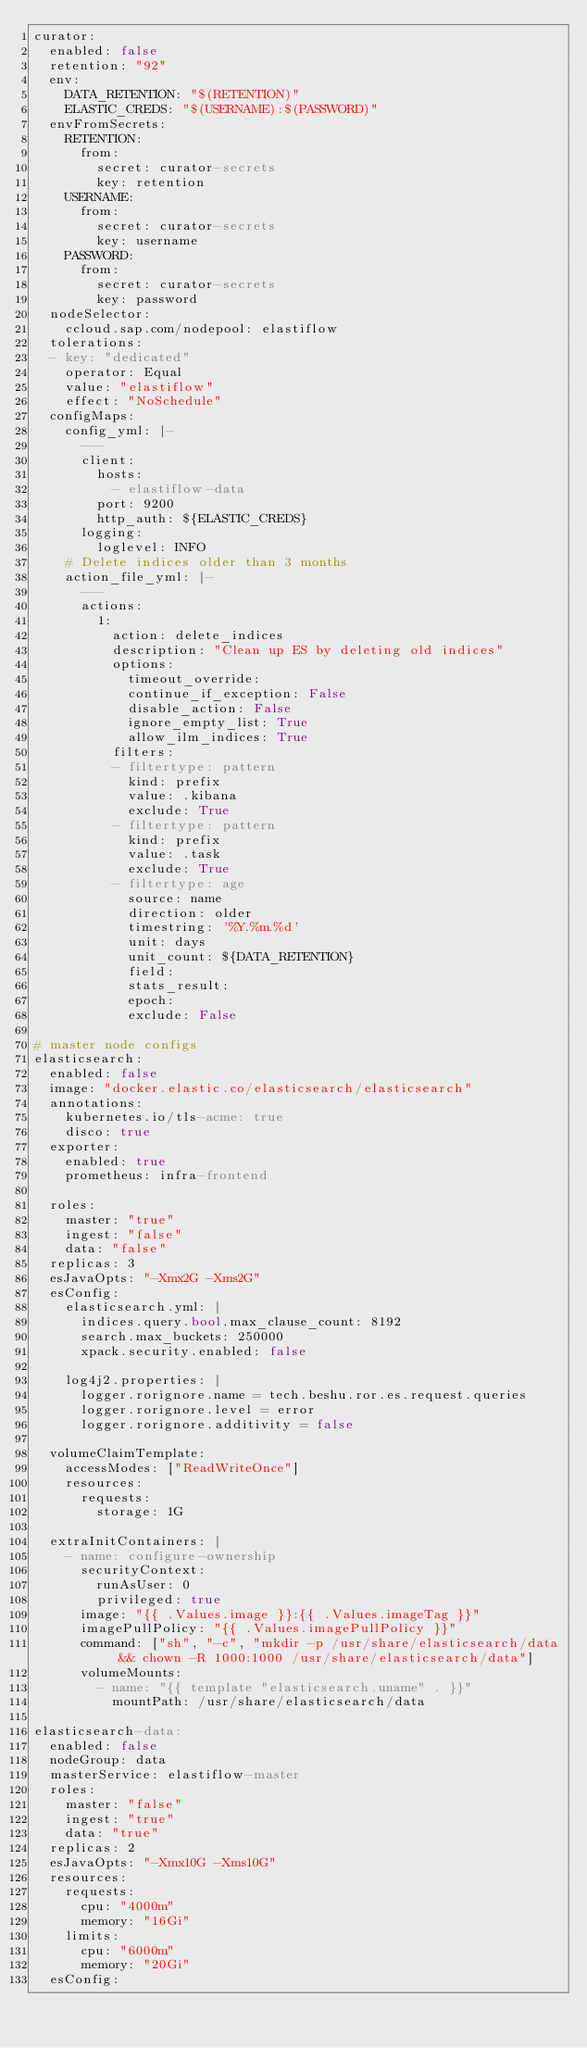Convert code to text. <code><loc_0><loc_0><loc_500><loc_500><_YAML_>curator:
  enabled: false
  retention: "92"
  env:
    DATA_RETENTION: "$(RETENTION)"
    ELASTIC_CREDS: "$(USERNAME):$(PASSWORD)"
  envFromSecrets:
    RETENTION:
      from:
        secret: curator-secrets
        key: retention
    USERNAME:
      from:
        secret: curator-secrets
        key: username
    PASSWORD:
      from:
        secret: curator-secrets
        key: password
  nodeSelector:
    ccloud.sap.com/nodepool: elastiflow
  tolerations:
  - key: "dedicated"
    operator: Equal
    value: "elastiflow"
    effect: "NoSchedule"
  configMaps:
    config_yml: |-
      ---
      client:
        hosts:
          - elastiflow-data
        port: 9200
        http_auth: ${ELASTIC_CREDS}
      logging:
        loglevel: INFO
    # Delete indices older than 3 months
    action_file_yml: |-
      ---
      actions:
        1:
          action: delete_indices
          description: "Clean up ES by deleting old indices"
          options:
            timeout_override:
            continue_if_exception: False
            disable_action: False
            ignore_empty_list: True
            allow_ilm_indices: True
          filters:
          - filtertype: pattern
            kind: prefix
            value: .kibana
            exclude: True
          - filtertype: pattern
            kind: prefix
            value: .task
            exclude: True
          - filtertype: age
            source: name
            direction: older
            timestring: '%Y.%m.%d'
            unit: days
            unit_count: ${DATA_RETENTION}
            field:
            stats_result:
            epoch:
            exclude: False

# master node configs
elasticsearch:
  enabled: false
  image: "docker.elastic.co/elasticsearch/elasticsearch"
  annotations:
    kubernetes.io/tls-acme: true
    disco: true
  exporter:
    enabled: true
    prometheus: infra-frontend

  roles:
    master: "true"
    ingest: "false"
    data: "false"
  replicas: 3
  esJavaOpts: "-Xmx2G -Xms2G"
  esConfig:
    elasticsearch.yml: |
      indices.query.bool.max_clause_count: 8192
      search.max_buckets: 250000
      xpack.security.enabled: false

    log4j2.properties: |
      logger.rorignore.name = tech.beshu.ror.es.request.queries
      logger.rorignore.level = error
      logger.rorignore.additivity = false

  volumeClaimTemplate:
    accessModes: ["ReadWriteOnce"]
    resources:
      requests:
        storage: 1G
        
  extraInitContainers: |
    - name: configure-ownership
      securityContext:
        runAsUser: 0
        privileged: true
      image: "{{ .Values.image }}:{{ .Values.imageTag }}"
      imagePullPolicy: "{{ .Values.imagePullPolicy }}"
      command: ["sh", "-c", "mkdir -p /usr/share/elasticsearch/data && chown -R 1000:1000 /usr/share/elasticsearch/data"]
      volumeMounts:
        - name: "{{ template "elasticsearch.uname" . }}"
          mountPath: /usr/share/elasticsearch/data

elasticsearch-data:
  enabled: false
  nodeGroup: data
  masterService: elastiflow-master
  roles:
    master: "false"
    ingest: "true"
    data: "true"
  replicas: 2
  esJavaOpts: "-Xmx10G -Xms10G"
  resources:
    requests:
      cpu: "4000m"
      memory: "16Gi"
    limits:
      cpu: "6000m"
      memory: "20Gi"
  esConfig:</code> 